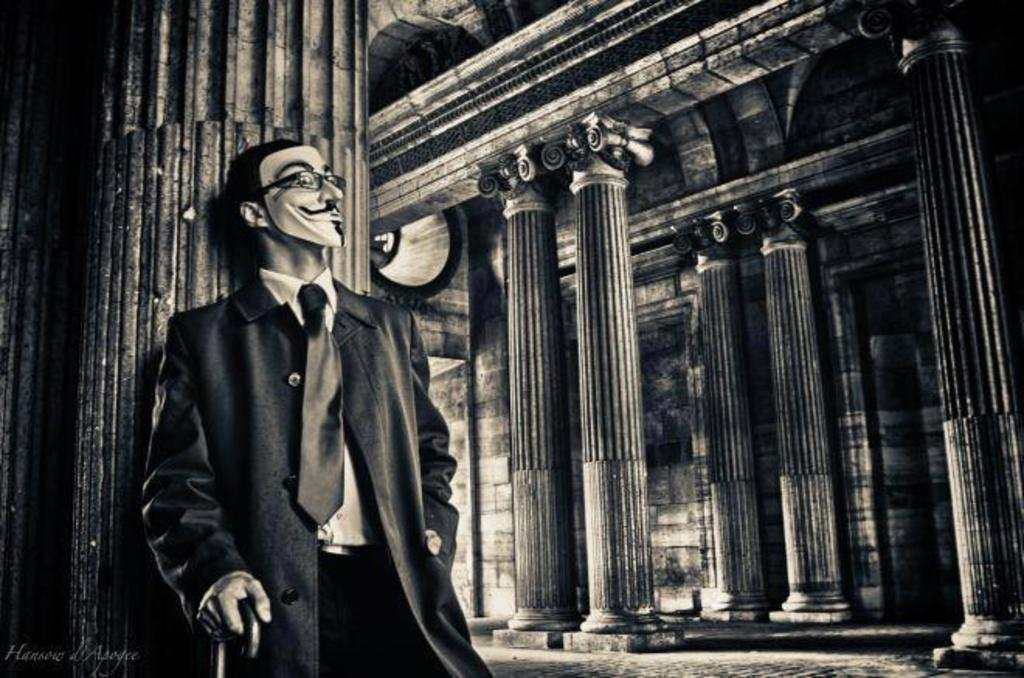Who is present in the image? There is a man in the image. What is the man doing in the image? The man is standing near a pillar and holding a stick. What is the man wearing in the image? The man is wearing a mask. How many pillars can be seen in the image? There are pillars in the image. What is on the right side of the image? There is a wall on the right side of the image. What type of quartz can be seen on the man's shoe in the image? There is no quartz or shoe present in the image. How does the smoke from the man's stick affect the visibility in the image? There is no smoke or indication of the man using the stick to create smoke in the image. 